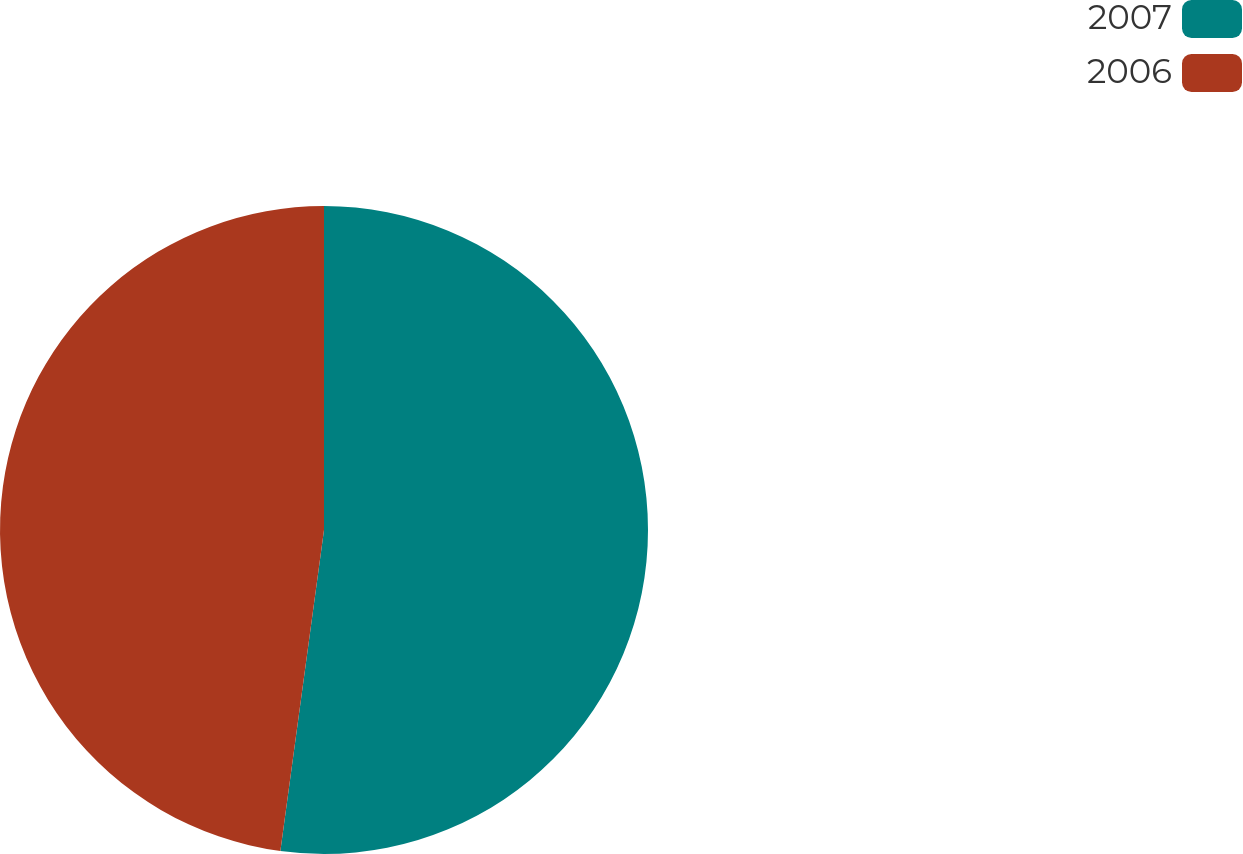Convert chart to OTSL. <chart><loc_0><loc_0><loc_500><loc_500><pie_chart><fcel>2007<fcel>2006<nl><fcel>52.15%<fcel>47.85%<nl></chart> 